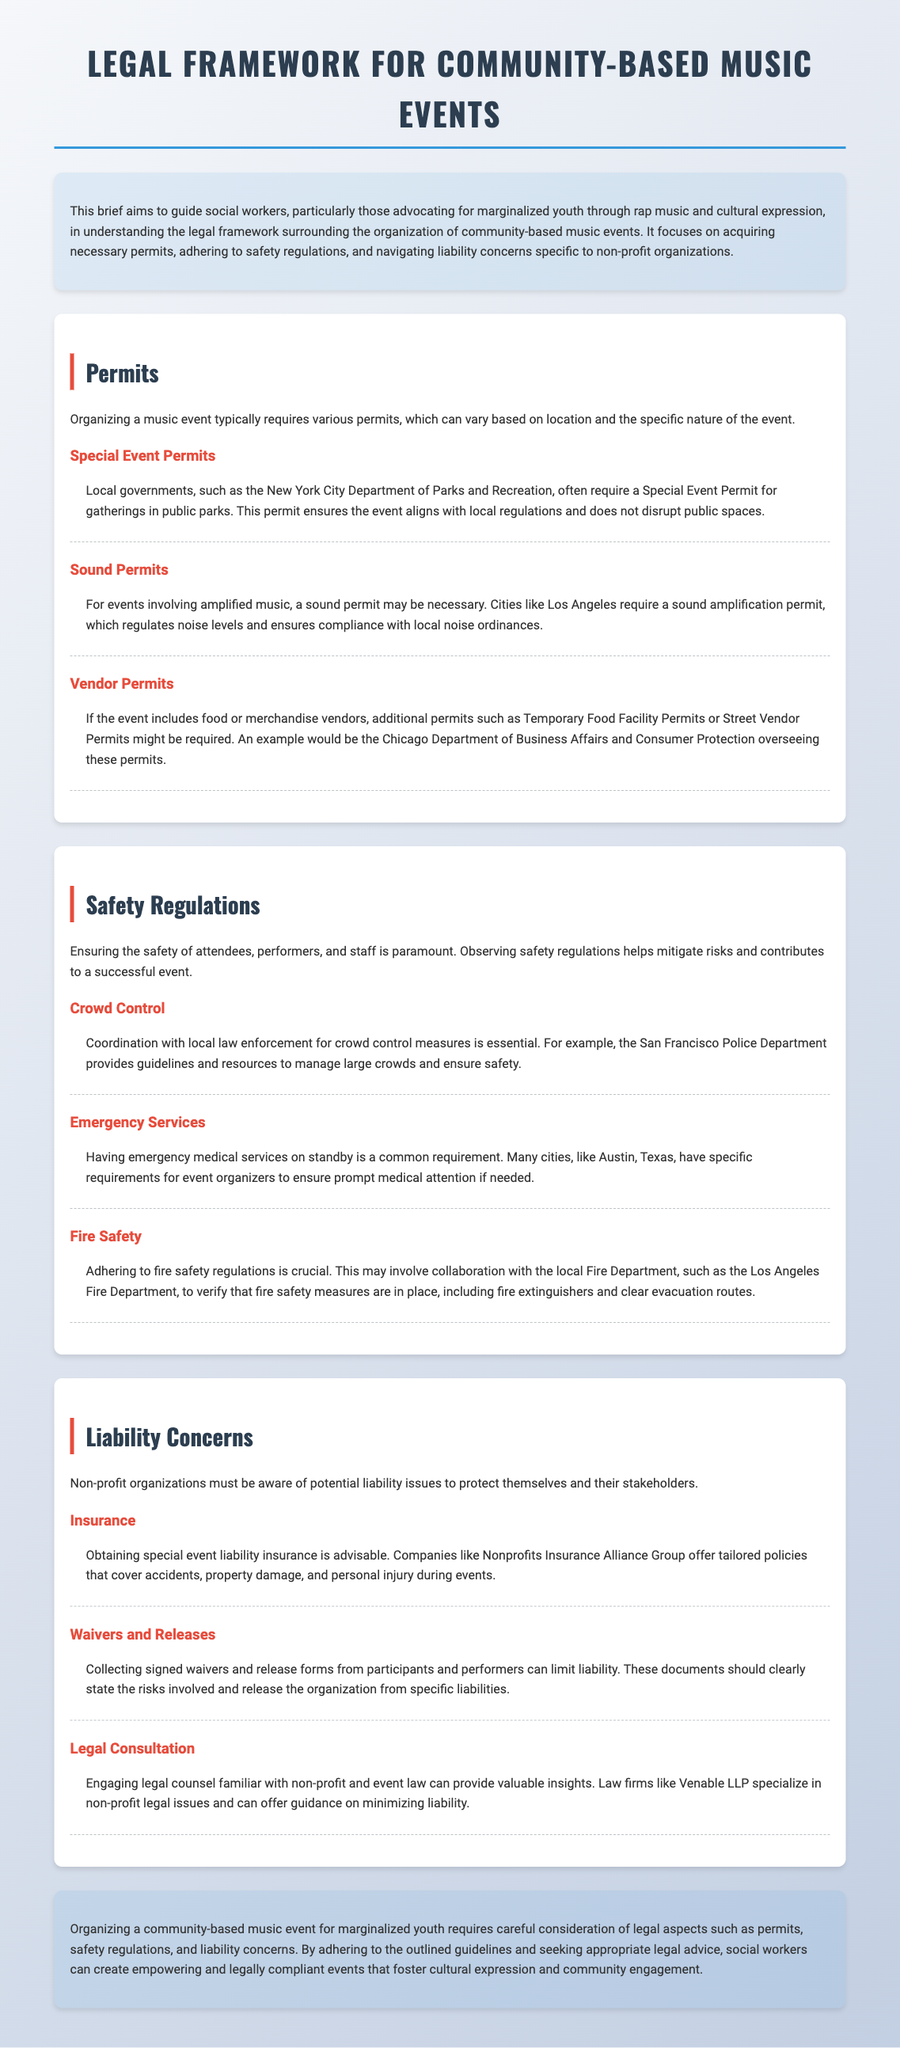What is the title of the document? The title of the document is located in the header section and states the focus of the brief.
Answer: Legal Framework for Community-based Music Events What type of organizations is this legal framework aimed at? The introduction specifies the kind of organization that the legal framework benefits.
Answer: Non-profit organizations What is required for amplified music events? This information is found in the section discussing permits, specifically related to noise regulations.
Answer: Sound permit Which local department oversees vendor permits in Chicago? Specific details about vendor permits can be found in the key points under the Permits section.
Answer: Chicago Department of Business Affairs and Consumer Protection What should be coordinated with local law enforcement? This aspect is addressed under the Safety Regulations section, which highlights essential safety measures.
Answer: Crowd control What type of insurance is recommended for event organizers? This requirement is mentioned in the Liability Concerns section, addressing how to mitigate risks.
Answer: Special event liability insurance Why are waivers and release forms important? The key points in the Liability Concerns section explain their relevance to protecting against liability.
Answer: Limit liability Which law firm specializes in non-profit legal issues? The document offers an example of legal counsel that can assist with relevant concerns in the Liability section.
Answer: Venable LLP What is a common requirement for emergency preparedness? This information is located in the Safety Regulations section, where emergency services are discussed.
Answer: Emergency medical services on standby 